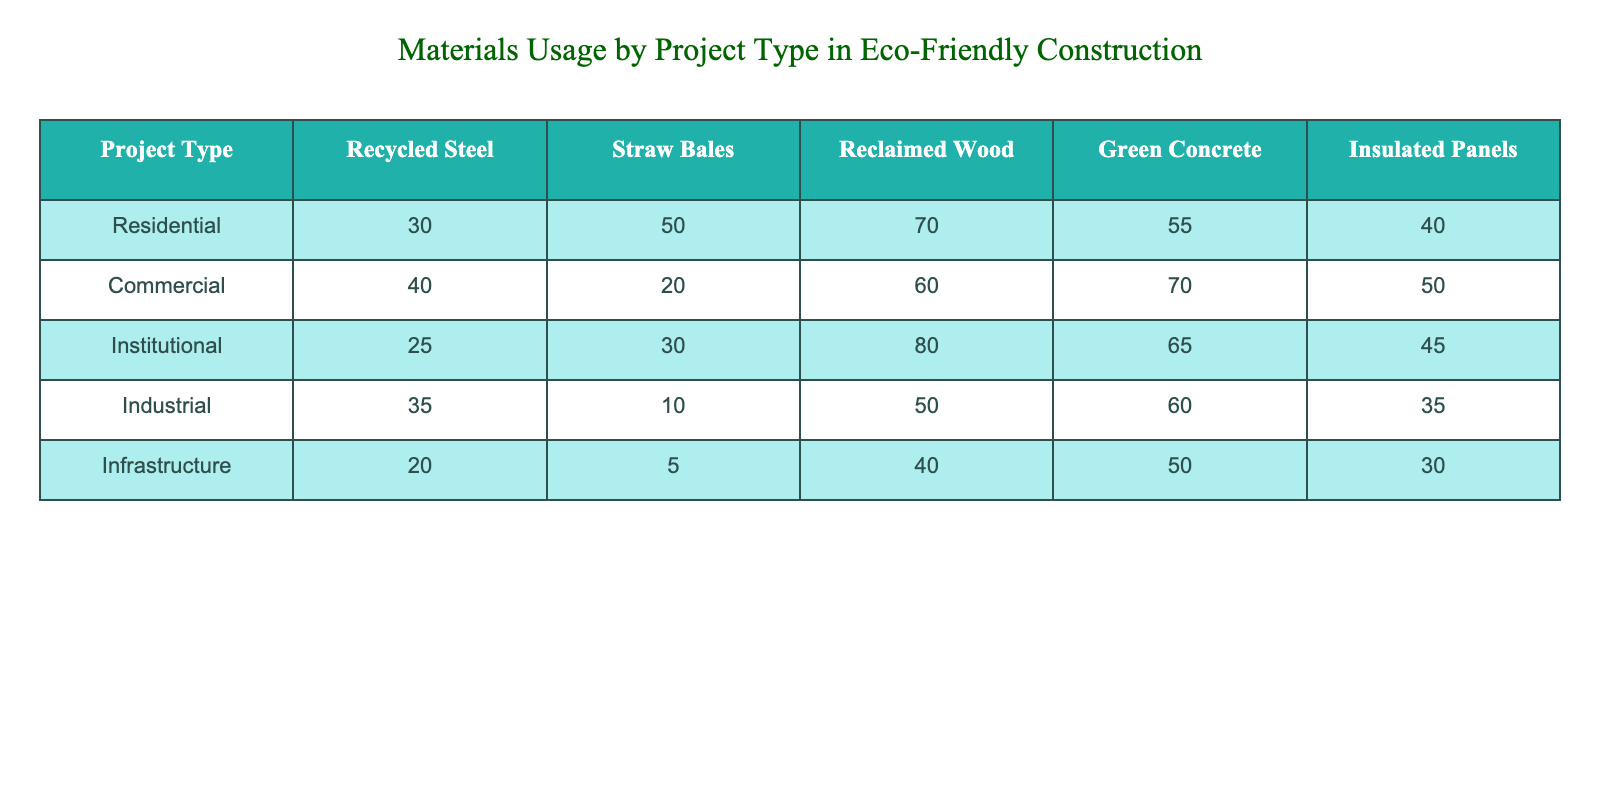What project type uses the most Recycled Steel? Looking at the Recycled Steel column, the Residential project type has the highest value of 30.
Answer: Residential What is the total usage of Green Concrete across all project types? To find the total usage, we add the values in the Green Concrete column: 55 (Residential) + 70 (Commercial) + 65 (Institutional) + 60 (Industrial) + 50 (Infrastructure) = 300.
Answer: 300 Does Institutional construction use more Straw Bales than Industrial construction? The value for Institutional is 30 while for Industrial, it is 10. Since 30 is greater than 10, the answer is yes.
Answer: Yes Which project type uses the least Insulated Panels? By examining the Insulated Panels column, the Infrastructure project type has the least value of 30.
Answer: Infrastructure What is the average usage of Reclaimed Wood for all project types? To calculate the average, we first add the values: 70 (Residential) + 60 (Commercial) + 80 (Institutional) + 50 (Industrial) + 40 (Infrastructure) = 300. There are 5 project types, so the average is 300/5 = 60.
Answer: 60 Is the total quantity of materials used in Residential construction greater than in Industrial construction? We sum the materials used in each: Residential = 30 + 50 + 70 + 55 + 40 = 245, and Industrial = 35 + 10 + 50 + 60 + 35 = 190. Since 245 is greater than 190, the answer is yes.
Answer: Yes What material is used the most in Commercial construction? Looking at the Commercial row, Green Concrete has the highest value at 70 compared to the others.
Answer: Green Concrete How much more Reclaimed Wood is used in Institutional projects than in Infrastructure projects? The value for Institutional is 80 and for Infrastructure, it is 40. Subtracting these gives 80 - 40 = 40.
Answer: 40 What is the difference in usage of Recycled Steel between the Residential and Commercial project types? The value for Residential is 30 and for Commercial is 40. To find the difference, we subtract Residential's usage from Commercial's: 40 - 30 = 10.
Answer: 10 